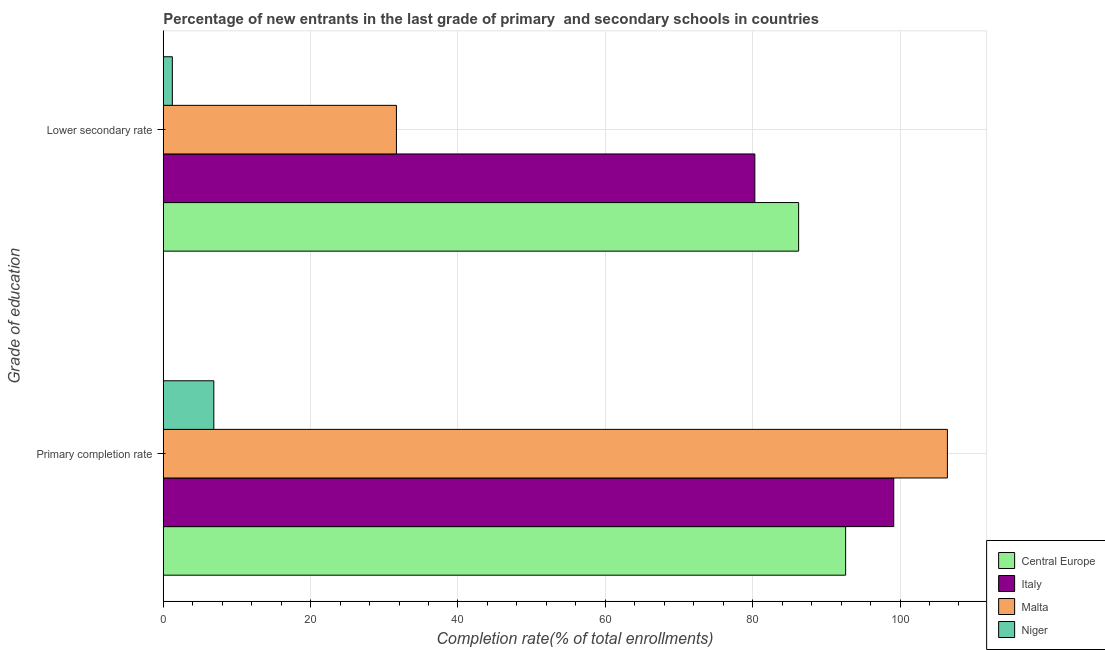What is the label of the 1st group of bars from the top?
Ensure brevity in your answer.  Lower secondary rate. What is the completion rate in primary schools in Central Europe?
Give a very brief answer. 92.62. Across all countries, what is the maximum completion rate in secondary schools?
Provide a succinct answer. 86.23. Across all countries, what is the minimum completion rate in primary schools?
Your response must be concise. 6.86. In which country was the completion rate in secondary schools maximum?
Your answer should be very brief. Central Europe. In which country was the completion rate in primary schools minimum?
Offer a very short reply. Niger. What is the total completion rate in primary schools in the graph?
Make the answer very short. 305.05. What is the difference between the completion rate in primary schools in Niger and that in Italy?
Make the answer very short. -92.28. What is the difference between the completion rate in primary schools in Malta and the completion rate in secondary schools in Niger?
Provide a succinct answer. 105.2. What is the average completion rate in secondary schools per country?
Offer a terse response. 49.85. What is the difference between the completion rate in secondary schools and completion rate in primary schools in Malta?
Offer a very short reply. -74.78. What is the ratio of the completion rate in secondary schools in Malta to that in Central Europe?
Offer a very short reply. 0.37. In how many countries, is the completion rate in secondary schools greater than the average completion rate in secondary schools taken over all countries?
Your answer should be compact. 2. What does the 3rd bar from the top in Primary completion rate represents?
Keep it short and to the point. Italy. What does the 2nd bar from the bottom in Primary completion rate represents?
Provide a short and direct response. Italy. Are all the bars in the graph horizontal?
Offer a terse response. Yes. What is the difference between two consecutive major ticks on the X-axis?
Offer a terse response. 20. Where does the legend appear in the graph?
Make the answer very short. Bottom right. How many legend labels are there?
Your answer should be compact. 4. What is the title of the graph?
Provide a succinct answer. Percentage of new entrants in the last grade of primary  and secondary schools in countries. What is the label or title of the X-axis?
Keep it short and to the point. Completion rate(% of total enrollments). What is the label or title of the Y-axis?
Your response must be concise. Grade of education. What is the Completion rate(% of total enrollments) in Central Europe in Primary completion rate?
Keep it short and to the point. 92.62. What is the Completion rate(% of total enrollments) in Italy in Primary completion rate?
Keep it short and to the point. 99.14. What is the Completion rate(% of total enrollments) in Malta in Primary completion rate?
Your answer should be compact. 106.43. What is the Completion rate(% of total enrollments) of Niger in Primary completion rate?
Keep it short and to the point. 6.86. What is the Completion rate(% of total enrollments) in Central Europe in Lower secondary rate?
Offer a terse response. 86.23. What is the Completion rate(% of total enrollments) of Italy in Lower secondary rate?
Your answer should be compact. 80.29. What is the Completion rate(% of total enrollments) in Malta in Lower secondary rate?
Offer a very short reply. 31.65. What is the Completion rate(% of total enrollments) in Niger in Lower secondary rate?
Provide a short and direct response. 1.23. Across all Grade of education, what is the maximum Completion rate(% of total enrollments) of Central Europe?
Give a very brief answer. 92.62. Across all Grade of education, what is the maximum Completion rate(% of total enrollments) in Italy?
Your answer should be compact. 99.14. Across all Grade of education, what is the maximum Completion rate(% of total enrollments) in Malta?
Offer a terse response. 106.43. Across all Grade of education, what is the maximum Completion rate(% of total enrollments) in Niger?
Make the answer very short. 6.86. Across all Grade of education, what is the minimum Completion rate(% of total enrollments) of Central Europe?
Provide a succinct answer. 86.23. Across all Grade of education, what is the minimum Completion rate(% of total enrollments) in Italy?
Your answer should be very brief. 80.29. Across all Grade of education, what is the minimum Completion rate(% of total enrollments) of Malta?
Provide a succinct answer. 31.65. Across all Grade of education, what is the minimum Completion rate(% of total enrollments) in Niger?
Give a very brief answer. 1.23. What is the total Completion rate(% of total enrollments) in Central Europe in the graph?
Give a very brief answer. 178.85. What is the total Completion rate(% of total enrollments) in Italy in the graph?
Offer a very short reply. 179.44. What is the total Completion rate(% of total enrollments) of Malta in the graph?
Your answer should be very brief. 138.08. What is the total Completion rate(% of total enrollments) of Niger in the graph?
Your response must be concise. 8.09. What is the difference between the Completion rate(% of total enrollments) of Central Europe in Primary completion rate and that in Lower secondary rate?
Offer a terse response. 6.38. What is the difference between the Completion rate(% of total enrollments) of Italy in Primary completion rate and that in Lower secondary rate?
Your answer should be compact. 18.85. What is the difference between the Completion rate(% of total enrollments) of Malta in Primary completion rate and that in Lower secondary rate?
Provide a succinct answer. 74.78. What is the difference between the Completion rate(% of total enrollments) of Niger in Primary completion rate and that in Lower secondary rate?
Your response must be concise. 5.63. What is the difference between the Completion rate(% of total enrollments) in Central Europe in Primary completion rate and the Completion rate(% of total enrollments) in Italy in Lower secondary rate?
Your response must be concise. 12.32. What is the difference between the Completion rate(% of total enrollments) of Central Europe in Primary completion rate and the Completion rate(% of total enrollments) of Malta in Lower secondary rate?
Provide a short and direct response. 60.97. What is the difference between the Completion rate(% of total enrollments) in Central Europe in Primary completion rate and the Completion rate(% of total enrollments) in Niger in Lower secondary rate?
Offer a very short reply. 91.38. What is the difference between the Completion rate(% of total enrollments) of Italy in Primary completion rate and the Completion rate(% of total enrollments) of Malta in Lower secondary rate?
Your answer should be very brief. 67.5. What is the difference between the Completion rate(% of total enrollments) in Italy in Primary completion rate and the Completion rate(% of total enrollments) in Niger in Lower secondary rate?
Ensure brevity in your answer.  97.91. What is the difference between the Completion rate(% of total enrollments) of Malta in Primary completion rate and the Completion rate(% of total enrollments) of Niger in Lower secondary rate?
Offer a very short reply. 105.2. What is the average Completion rate(% of total enrollments) in Central Europe per Grade of education?
Give a very brief answer. 89.43. What is the average Completion rate(% of total enrollments) of Italy per Grade of education?
Ensure brevity in your answer.  89.72. What is the average Completion rate(% of total enrollments) of Malta per Grade of education?
Provide a short and direct response. 69.04. What is the average Completion rate(% of total enrollments) in Niger per Grade of education?
Your answer should be very brief. 4.05. What is the difference between the Completion rate(% of total enrollments) in Central Europe and Completion rate(% of total enrollments) in Italy in Primary completion rate?
Keep it short and to the point. -6.53. What is the difference between the Completion rate(% of total enrollments) in Central Europe and Completion rate(% of total enrollments) in Malta in Primary completion rate?
Make the answer very short. -13.81. What is the difference between the Completion rate(% of total enrollments) in Central Europe and Completion rate(% of total enrollments) in Niger in Primary completion rate?
Give a very brief answer. 85.75. What is the difference between the Completion rate(% of total enrollments) in Italy and Completion rate(% of total enrollments) in Malta in Primary completion rate?
Give a very brief answer. -7.29. What is the difference between the Completion rate(% of total enrollments) in Italy and Completion rate(% of total enrollments) in Niger in Primary completion rate?
Ensure brevity in your answer.  92.28. What is the difference between the Completion rate(% of total enrollments) in Malta and Completion rate(% of total enrollments) in Niger in Primary completion rate?
Ensure brevity in your answer.  99.57. What is the difference between the Completion rate(% of total enrollments) of Central Europe and Completion rate(% of total enrollments) of Italy in Lower secondary rate?
Keep it short and to the point. 5.94. What is the difference between the Completion rate(% of total enrollments) in Central Europe and Completion rate(% of total enrollments) in Malta in Lower secondary rate?
Your answer should be compact. 54.59. What is the difference between the Completion rate(% of total enrollments) in Central Europe and Completion rate(% of total enrollments) in Niger in Lower secondary rate?
Give a very brief answer. 85. What is the difference between the Completion rate(% of total enrollments) of Italy and Completion rate(% of total enrollments) of Malta in Lower secondary rate?
Ensure brevity in your answer.  48.65. What is the difference between the Completion rate(% of total enrollments) of Italy and Completion rate(% of total enrollments) of Niger in Lower secondary rate?
Make the answer very short. 79.06. What is the difference between the Completion rate(% of total enrollments) of Malta and Completion rate(% of total enrollments) of Niger in Lower secondary rate?
Your answer should be compact. 30.42. What is the ratio of the Completion rate(% of total enrollments) of Central Europe in Primary completion rate to that in Lower secondary rate?
Offer a terse response. 1.07. What is the ratio of the Completion rate(% of total enrollments) in Italy in Primary completion rate to that in Lower secondary rate?
Your answer should be very brief. 1.23. What is the ratio of the Completion rate(% of total enrollments) in Malta in Primary completion rate to that in Lower secondary rate?
Provide a short and direct response. 3.36. What is the ratio of the Completion rate(% of total enrollments) of Niger in Primary completion rate to that in Lower secondary rate?
Ensure brevity in your answer.  5.57. What is the difference between the highest and the second highest Completion rate(% of total enrollments) in Central Europe?
Offer a terse response. 6.38. What is the difference between the highest and the second highest Completion rate(% of total enrollments) of Italy?
Your answer should be compact. 18.85. What is the difference between the highest and the second highest Completion rate(% of total enrollments) of Malta?
Provide a succinct answer. 74.78. What is the difference between the highest and the second highest Completion rate(% of total enrollments) in Niger?
Your response must be concise. 5.63. What is the difference between the highest and the lowest Completion rate(% of total enrollments) in Central Europe?
Provide a short and direct response. 6.38. What is the difference between the highest and the lowest Completion rate(% of total enrollments) in Italy?
Your response must be concise. 18.85. What is the difference between the highest and the lowest Completion rate(% of total enrollments) in Malta?
Your answer should be compact. 74.78. What is the difference between the highest and the lowest Completion rate(% of total enrollments) in Niger?
Keep it short and to the point. 5.63. 